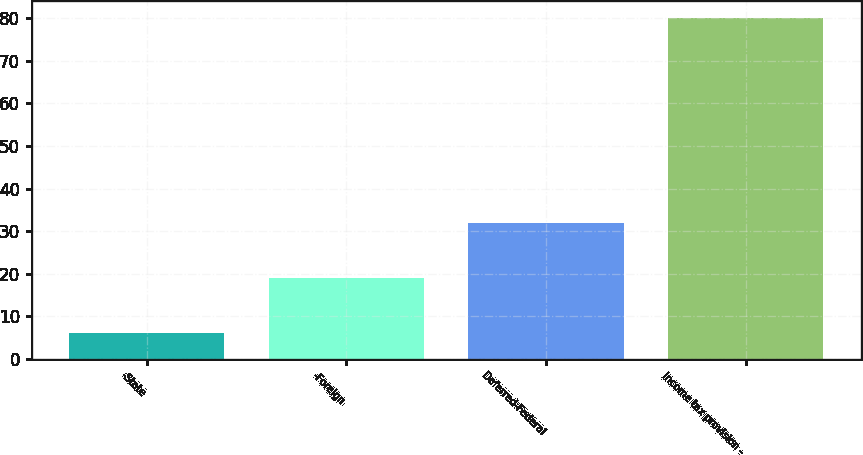Convert chart. <chart><loc_0><loc_0><loc_500><loc_500><bar_chart><fcel>-State<fcel>-Foreign<fcel>Deferred-Federal<fcel>Income tax provision -<nl><fcel>6<fcel>19<fcel>32<fcel>80<nl></chart> 